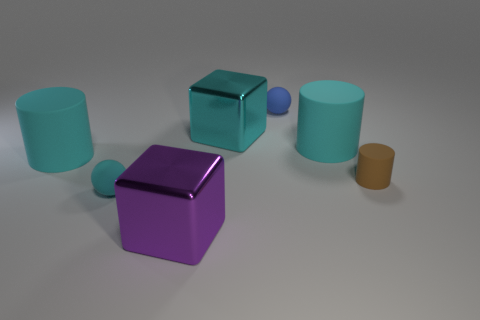Subtract all purple balls. How many cyan cylinders are left? 2 Subtract all brown cylinders. How many cylinders are left? 2 Add 2 small blue rubber spheres. How many objects exist? 9 Subtract all yellow cylinders. Subtract all red cubes. How many cylinders are left? 3 Add 1 blocks. How many blocks are left? 3 Add 3 purple shiny cubes. How many purple shiny cubes exist? 4 Subtract 0 yellow cylinders. How many objects are left? 7 Subtract all blocks. How many objects are left? 5 Subtract all large purple shiny objects. Subtract all small spheres. How many objects are left? 4 